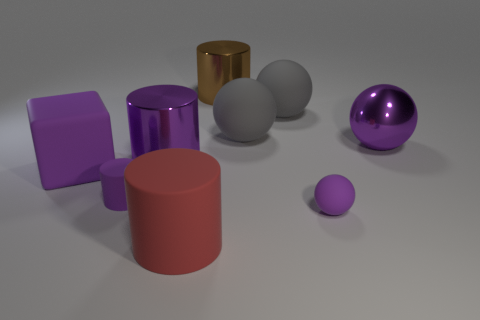What number of objects are to the right of the large red matte cylinder and behind the rubber block?
Make the answer very short. 4. What number of other things are the same shape as the big brown thing?
Your answer should be compact. 3. Is the number of big purple rubber blocks that are on the right side of the big purple metallic cylinder greater than the number of large metal cubes?
Provide a short and direct response. No. There is a metallic sphere that is behind the tiny ball; what is its color?
Keep it short and to the point. Purple. There is another sphere that is the same color as the small sphere; what is its size?
Provide a short and direct response. Large. What number of shiny objects are purple objects or cubes?
Offer a terse response. 2. There is a tiny rubber thing behind the small purple rubber thing right of the red cylinder; are there any small purple rubber cylinders that are in front of it?
Offer a terse response. No. There is a big red thing; what number of large cylinders are left of it?
Provide a short and direct response. 1. There is a small ball that is the same color as the cube; what material is it?
Provide a succinct answer. Rubber. How many large things are either blue metal spheres or shiny cylinders?
Ensure brevity in your answer.  2. 